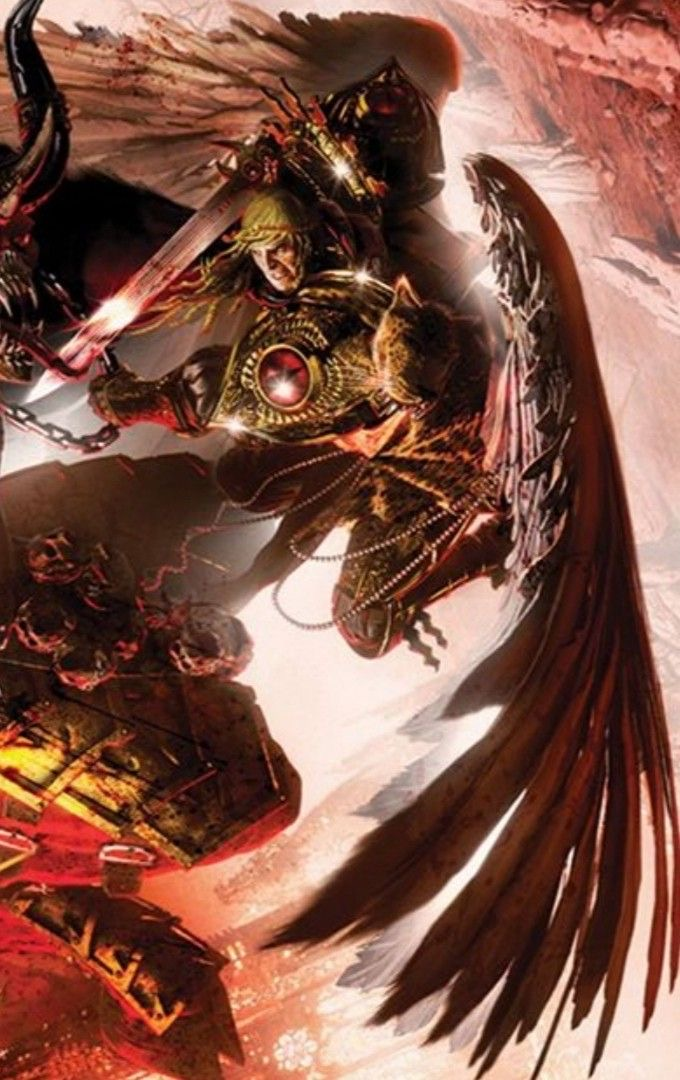describe  The image features a dynamic and detailed illustration of a fantasy or science fiction character. The character appears to be armored and is wielding a weapon that glows with energy, suggesting a blend of medieval and futuristic elements.

The armor is ornate and intricate, with a color scheme dominated by golds and dark tones, accented with reds and greens. The character's helmet has a crest and a visor, which partially obscures the face, revealing only the eyes. The armor is adorned with chains, decorative patterns, and a prominent circular symbol on the chest, which could be an emblem or a power source.

One of the most striking features of the character is a pair of large, mechanical-looking wings that extend outward. The wings have feathers or feather-like structures, but they also have metallic or mechanical components, giving them an artificial appearance.

The background is less defined but suggests a chaotic environment with reddish hues, which could be indicative of a battlefield or a desolate, alien landscape. The motion and energy in the image are palpable, evoking a sense of action and intensity. 